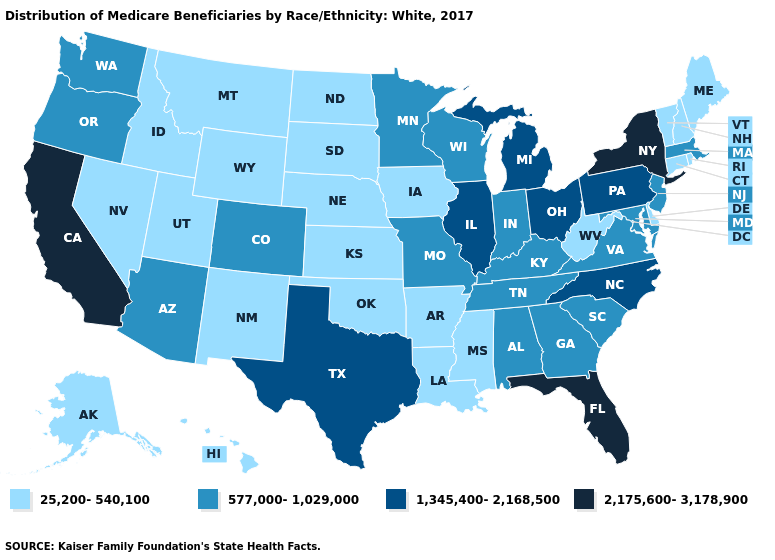Is the legend a continuous bar?
Short answer required. No. Does Indiana have the same value as Arkansas?
Give a very brief answer. No. Among the states that border Minnesota , which have the highest value?
Concise answer only. Wisconsin. Name the states that have a value in the range 25,200-540,100?
Write a very short answer. Alaska, Arkansas, Connecticut, Delaware, Hawaii, Idaho, Iowa, Kansas, Louisiana, Maine, Mississippi, Montana, Nebraska, Nevada, New Hampshire, New Mexico, North Dakota, Oklahoma, Rhode Island, South Dakota, Utah, Vermont, West Virginia, Wyoming. Which states have the highest value in the USA?
Give a very brief answer. California, Florida, New York. Does Alabama have the lowest value in the USA?
Concise answer only. No. What is the lowest value in the South?
Quick response, please. 25,200-540,100. What is the value of Georgia?
Quick response, please. 577,000-1,029,000. Among the states that border Pennsylvania , which have the lowest value?
Write a very short answer. Delaware, West Virginia. What is the lowest value in the USA?
Write a very short answer. 25,200-540,100. Which states hav the highest value in the South?
Be succinct. Florida. Name the states that have a value in the range 2,175,600-3,178,900?
Quick response, please. California, Florida, New York. What is the highest value in the Northeast ?
Concise answer only. 2,175,600-3,178,900. What is the value of Kentucky?
Quick response, please. 577,000-1,029,000. Among the states that border Illinois , does Kentucky have the highest value?
Give a very brief answer. Yes. 